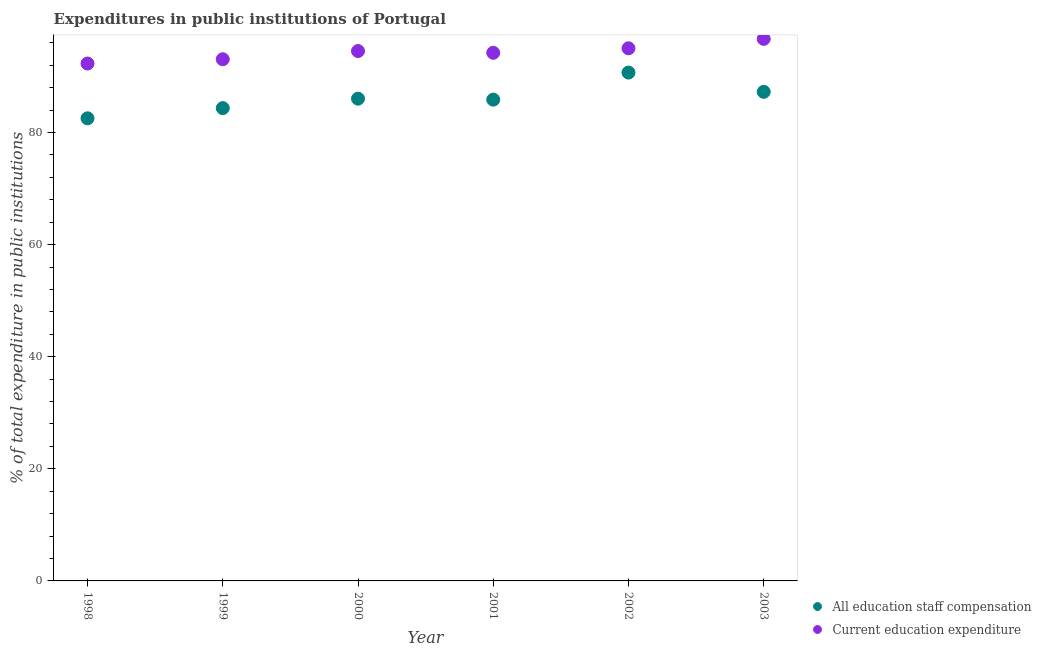How many different coloured dotlines are there?
Keep it short and to the point. 2. Is the number of dotlines equal to the number of legend labels?
Keep it short and to the point. Yes. What is the expenditure in staff compensation in 2001?
Make the answer very short. 85.87. Across all years, what is the maximum expenditure in staff compensation?
Keep it short and to the point. 90.69. Across all years, what is the minimum expenditure in education?
Provide a short and direct response. 92.31. What is the total expenditure in education in the graph?
Offer a very short reply. 565.87. What is the difference between the expenditure in staff compensation in 2002 and that in 2003?
Your answer should be very brief. 3.44. What is the difference between the expenditure in education in 2002 and the expenditure in staff compensation in 1998?
Offer a terse response. 12.49. What is the average expenditure in staff compensation per year?
Offer a very short reply. 86.12. In the year 2000, what is the difference between the expenditure in education and expenditure in staff compensation?
Your answer should be very brief. 8.5. In how many years, is the expenditure in staff compensation greater than 92 %?
Give a very brief answer. 0. What is the ratio of the expenditure in education in 2000 to that in 2002?
Keep it short and to the point. 0.99. What is the difference between the highest and the second highest expenditure in staff compensation?
Your answer should be very brief. 3.44. What is the difference between the highest and the lowest expenditure in staff compensation?
Your answer should be very brief. 8.16. In how many years, is the expenditure in staff compensation greater than the average expenditure in staff compensation taken over all years?
Offer a very short reply. 2. Is the expenditure in staff compensation strictly greater than the expenditure in education over the years?
Your answer should be very brief. No. How many years are there in the graph?
Your answer should be very brief. 6. What is the difference between two consecutive major ticks on the Y-axis?
Give a very brief answer. 20. Does the graph contain any zero values?
Ensure brevity in your answer.  No. Does the graph contain grids?
Give a very brief answer. No. Where does the legend appear in the graph?
Your response must be concise. Bottom right. What is the title of the graph?
Your answer should be very brief. Expenditures in public institutions of Portugal. What is the label or title of the X-axis?
Offer a very short reply. Year. What is the label or title of the Y-axis?
Offer a terse response. % of total expenditure in public institutions. What is the % of total expenditure in public institutions in All education staff compensation in 1998?
Your response must be concise. 82.53. What is the % of total expenditure in public institutions in Current education expenditure in 1998?
Make the answer very short. 92.31. What is the % of total expenditure in public institutions of All education staff compensation in 1999?
Keep it short and to the point. 84.36. What is the % of total expenditure in public institutions in Current education expenditure in 1999?
Ensure brevity in your answer.  93.07. What is the % of total expenditure in public institutions of All education staff compensation in 2000?
Ensure brevity in your answer.  86.04. What is the % of total expenditure in public institutions in Current education expenditure in 2000?
Offer a terse response. 94.54. What is the % of total expenditure in public institutions in All education staff compensation in 2001?
Provide a succinct answer. 85.87. What is the % of total expenditure in public institutions of Current education expenditure in 2001?
Keep it short and to the point. 94.22. What is the % of total expenditure in public institutions of All education staff compensation in 2002?
Your answer should be very brief. 90.69. What is the % of total expenditure in public institutions of Current education expenditure in 2002?
Provide a short and direct response. 95.03. What is the % of total expenditure in public institutions of All education staff compensation in 2003?
Your answer should be very brief. 87.26. What is the % of total expenditure in public institutions in Current education expenditure in 2003?
Keep it short and to the point. 96.71. Across all years, what is the maximum % of total expenditure in public institutions in All education staff compensation?
Provide a succinct answer. 90.69. Across all years, what is the maximum % of total expenditure in public institutions of Current education expenditure?
Offer a terse response. 96.71. Across all years, what is the minimum % of total expenditure in public institutions in All education staff compensation?
Your response must be concise. 82.53. Across all years, what is the minimum % of total expenditure in public institutions in Current education expenditure?
Give a very brief answer. 92.31. What is the total % of total expenditure in public institutions of All education staff compensation in the graph?
Your response must be concise. 516.74. What is the total % of total expenditure in public institutions of Current education expenditure in the graph?
Make the answer very short. 565.87. What is the difference between the % of total expenditure in public institutions of All education staff compensation in 1998 and that in 1999?
Ensure brevity in your answer.  -1.82. What is the difference between the % of total expenditure in public institutions of Current education expenditure in 1998 and that in 1999?
Offer a very short reply. -0.76. What is the difference between the % of total expenditure in public institutions of All education staff compensation in 1998 and that in 2000?
Offer a terse response. -3.5. What is the difference between the % of total expenditure in public institutions in Current education expenditure in 1998 and that in 2000?
Your answer should be very brief. -2.23. What is the difference between the % of total expenditure in public institutions of All education staff compensation in 1998 and that in 2001?
Offer a very short reply. -3.33. What is the difference between the % of total expenditure in public institutions of Current education expenditure in 1998 and that in 2001?
Your answer should be very brief. -1.91. What is the difference between the % of total expenditure in public institutions of All education staff compensation in 1998 and that in 2002?
Ensure brevity in your answer.  -8.16. What is the difference between the % of total expenditure in public institutions in Current education expenditure in 1998 and that in 2002?
Offer a terse response. -2.72. What is the difference between the % of total expenditure in public institutions in All education staff compensation in 1998 and that in 2003?
Ensure brevity in your answer.  -4.72. What is the difference between the % of total expenditure in public institutions in Current education expenditure in 1998 and that in 2003?
Give a very brief answer. -4.4. What is the difference between the % of total expenditure in public institutions of All education staff compensation in 1999 and that in 2000?
Keep it short and to the point. -1.68. What is the difference between the % of total expenditure in public institutions in Current education expenditure in 1999 and that in 2000?
Provide a short and direct response. -1.46. What is the difference between the % of total expenditure in public institutions in All education staff compensation in 1999 and that in 2001?
Your answer should be compact. -1.51. What is the difference between the % of total expenditure in public institutions of Current education expenditure in 1999 and that in 2001?
Keep it short and to the point. -1.15. What is the difference between the % of total expenditure in public institutions of All education staff compensation in 1999 and that in 2002?
Keep it short and to the point. -6.34. What is the difference between the % of total expenditure in public institutions in Current education expenditure in 1999 and that in 2002?
Offer a very short reply. -1.96. What is the difference between the % of total expenditure in public institutions in All education staff compensation in 1999 and that in 2003?
Your response must be concise. -2.9. What is the difference between the % of total expenditure in public institutions of Current education expenditure in 1999 and that in 2003?
Your answer should be very brief. -3.64. What is the difference between the % of total expenditure in public institutions of All education staff compensation in 2000 and that in 2001?
Give a very brief answer. 0.17. What is the difference between the % of total expenditure in public institutions in Current education expenditure in 2000 and that in 2001?
Give a very brief answer. 0.31. What is the difference between the % of total expenditure in public institutions in All education staff compensation in 2000 and that in 2002?
Offer a terse response. -4.66. What is the difference between the % of total expenditure in public institutions of Current education expenditure in 2000 and that in 2002?
Provide a short and direct response. -0.49. What is the difference between the % of total expenditure in public institutions in All education staff compensation in 2000 and that in 2003?
Give a very brief answer. -1.22. What is the difference between the % of total expenditure in public institutions in Current education expenditure in 2000 and that in 2003?
Keep it short and to the point. -2.18. What is the difference between the % of total expenditure in public institutions of All education staff compensation in 2001 and that in 2002?
Your answer should be compact. -4.83. What is the difference between the % of total expenditure in public institutions of Current education expenditure in 2001 and that in 2002?
Your answer should be very brief. -0.8. What is the difference between the % of total expenditure in public institutions of All education staff compensation in 2001 and that in 2003?
Your response must be concise. -1.39. What is the difference between the % of total expenditure in public institutions in Current education expenditure in 2001 and that in 2003?
Offer a terse response. -2.49. What is the difference between the % of total expenditure in public institutions of All education staff compensation in 2002 and that in 2003?
Your response must be concise. 3.44. What is the difference between the % of total expenditure in public institutions of Current education expenditure in 2002 and that in 2003?
Offer a very short reply. -1.68. What is the difference between the % of total expenditure in public institutions of All education staff compensation in 1998 and the % of total expenditure in public institutions of Current education expenditure in 1999?
Your response must be concise. -10.54. What is the difference between the % of total expenditure in public institutions in All education staff compensation in 1998 and the % of total expenditure in public institutions in Current education expenditure in 2000?
Your response must be concise. -12. What is the difference between the % of total expenditure in public institutions in All education staff compensation in 1998 and the % of total expenditure in public institutions in Current education expenditure in 2001?
Offer a very short reply. -11.69. What is the difference between the % of total expenditure in public institutions of All education staff compensation in 1998 and the % of total expenditure in public institutions of Current education expenditure in 2002?
Provide a succinct answer. -12.49. What is the difference between the % of total expenditure in public institutions of All education staff compensation in 1998 and the % of total expenditure in public institutions of Current education expenditure in 2003?
Provide a succinct answer. -14.18. What is the difference between the % of total expenditure in public institutions of All education staff compensation in 1999 and the % of total expenditure in public institutions of Current education expenditure in 2000?
Offer a very short reply. -10.18. What is the difference between the % of total expenditure in public institutions in All education staff compensation in 1999 and the % of total expenditure in public institutions in Current education expenditure in 2001?
Offer a terse response. -9.87. What is the difference between the % of total expenditure in public institutions in All education staff compensation in 1999 and the % of total expenditure in public institutions in Current education expenditure in 2002?
Make the answer very short. -10.67. What is the difference between the % of total expenditure in public institutions in All education staff compensation in 1999 and the % of total expenditure in public institutions in Current education expenditure in 2003?
Offer a terse response. -12.36. What is the difference between the % of total expenditure in public institutions in All education staff compensation in 2000 and the % of total expenditure in public institutions in Current education expenditure in 2001?
Your answer should be very brief. -8.19. What is the difference between the % of total expenditure in public institutions in All education staff compensation in 2000 and the % of total expenditure in public institutions in Current education expenditure in 2002?
Provide a succinct answer. -8.99. What is the difference between the % of total expenditure in public institutions of All education staff compensation in 2000 and the % of total expenditure in public institutions of Current education expenditure in 2003?
Provide a succinct answer. -10.67. What is the difference between the % of total expenditure in public institutions in All education staff compensation in 2001 and the % of total expenditure in public institutions in Current education expenditure in 2002?
Provide a short and direct response. -9.16. What is the difference between the % of total expenditure in public institutions of All education staff compensation in 2001 and the % of total expenditure in public institutions of Current education expenditure in 2003?
Give a very brief answer. -10.85. What is the difference between the % of total expenditure in public institutions of All education staff compensation in 2002 and the % of total expenditure in public institutions of Current education expenditure in 2003?
Ensure brevity in your answer.  -6.02. What is the average % of total expenditure in public institutions of All education staff compensation per year?
Provide a succinct answer. 86.12. What is the average % of total expenditure in public institutions of Current education expenditure per year?
Offer a terse response. 94.31. In the year 1998, what is the difference between the % of total expenditure in public institutions in All education staff compensation and % of total expenditure in public institutions in Current education expenditure?
Offer a terse response. -9.77. In the year 1999, what is the difference between the % of total expenditure in public institutions in All education staff compensation and % of total expenditure in public institutions in Current education expenditure?
Give a very brief answer. -8.72. In the year 2000, what is the difference between the % of total expenditure in public institutions of All education staff compensation and % of total expenditure in public institutions of Current education expenditure?
Ensure brevity in your answer.  -8.5. In the year 2001, what is the difference between the % of total expenditure in public institutions in All education staff compensation and % of total expenditure in public institutions in Current education expenditure?
Your response must be concise. -8.36. In the year 2002, what is the difference between the % of total expenditure in public institutions of All education staff compensation and % of total expenditure in public institutions of Current education expenditure?
Your answer should be very brief. -4.33. In the year 2003, what is the difference between the % of total expenditure in public institutions in All education staff compensation and % of total expenditure in public institutions in Current education expenditure?
Provide a succinct answer. -9.45. What is the ratio of the % of total expenditure in public institutions of All education staff compensation in 1998 to that in 1999?
Your answer should be compact. 0.98. What is the ratio of the % of total expenditure in public institutions in Current education expenditure in 1998 to that in 1999?
Provide a short and direct response. 0.99. What is the ratio of the % of total expenditure in public institutions of All education staff compensation in 1998 to that in 2000?
Your answer should be very brief. 0.96. What is the ratio of the % of total expenditure in public institutions in Current education expenditure in 1998 to that in 2000?
Your answer should be compact. 0.98. What is the ratio of the % of total expenditure in public institutions in All education staff compensation in 1998 to that in 2001?
Make the answer very short. 0.96. What is the ratio of the % of total expenditure in public institutions in Current education expenditure in 1998 to that in 2001?
Your answer should be very brief. 0.98. What is the ratio of the % of total expenditure in public institutions in All education staff compensation in 1998 to that in 2002?
Make the answer very short. 0.91. What is the ratio of the % of total expenditure in public institutions in Current education expenditure in 1998 to that in 2002?
Offer a terse response. 0.97. What is the ratio of the % of total expenditure in public institutions of All education staff compensation in 1998 to that in 2003?
Your answer should be very brief. 0.95. What is the ratio of the % of total expenditure in public institutions of Current education expenditure in 1998 to that in 2003?
Provide a succinct answer. 0.95. What is the ratio of the % of total expenditure in public institutions of All education staff compensation in 1999 to that in 2000?
Your answer should be very brief. 0.98. What is the ratio of the % of total expenditure in public institutions in Current education expenditure in 1999 to that in 2000?
Offer a terse response. 0.98. What is the ratio of the % of total expenditure in public institutions in All education staff compensation in 1999 to that in 2001?
Keep it short and to the point. 0.98. What is the ratio of the % of total expenditure in public institutions in Current education expenditure in 1999 to that in 2001?
Your answer should be compact. 0.99. What is the ratio of the % of total expenditure in public institutions in All education staff compensation in 1999 to that in 2002?
Your response must be concise. 0.93. What is the ratio of the % of total expenditure in public institutions of Current education expenditure in 1999 to that in 2002?
Offer a terse response. 0.98. What is the ratio of the % of total expenditure in public institutions in All education staff compensation in 1999 to that in 2003?
Keep it short and to the point. 0.97. What is the ratio of the % of total expenditure in public institutions of Current education expenditure in 1999 to that in 2003?
Make the answer very short. 0.96. What is the ratio of the % of total expenditure in public institutions of All education staff compensation in 2000 to that in 2002?
Offer a terse response. 0.95. What is the ratio of the % of total expenditure in public institutions of Current education expenditure in 2000 to that in 2003?
Offer a very short reply. 0.98. What is the ratio of the % of total expenditure in public institutions of All education staff compensation in 2001 to that in 2002?
Provide a short and direct response. 0.95. What is the ratio of the % of total expenditure in public institutions of Current education expenditure in 2001 to that in 2002?
Provide a short and direct response. 0.99. What is the ratio of the % of total expenditure in public institutions in All education staff compensation in 2001 to that in 2003?
Ensure brevity in your answer.  0.98. What is the ratio of the % of total expenditure in public institutions of Current education expenditure in 2001 to that in 2003?
Provide a short and direct response. 0.97. What is the ratio of the % of total expenditure in public institutions of All education staff compensation in 2002 to that in 2003?
Ensure brevity in your answer.  1.04. What is the ratio of the % of total expenditure in public institutions in Current education expenditure in 2002 to that in 2003?
Offer a terse response. 0.98. What is the difference between the highest and the second highest % of total expenditure in public institutions of All education staff compensation?
Ensure brevity in your answer.  3.44. What is the difference between the highest and the second highest % of total expenditure in public institutions of Current education expenditure?
Your response must be concise. 1.68. What is the difference between the highest and the lowest % of total expenditure in public institutions in All education staff compensation?
Make the answer very short. 8.16. What is the difference between the highest and the lowest % of total expenditure in public institutions in Current education expenditure?
Provide a short and direct response. 4.4. 